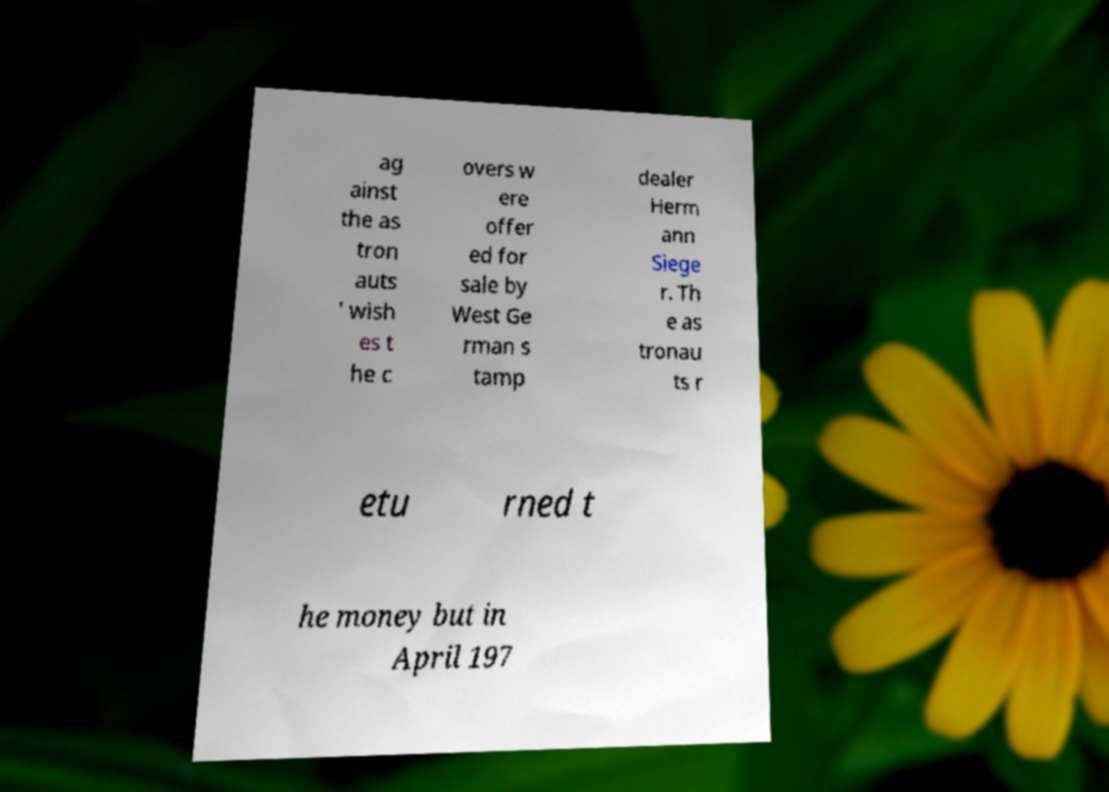There's text embedded in this image that I need extracted. Can you transcribe it verbatim? ag ainst the as tron auts ' wish es t he c overs w ere offer ed for sale by West Ge rman s tamp dealer Herm ann Siege r. Th e as tronau ts r etu rned t he money but in April 197 